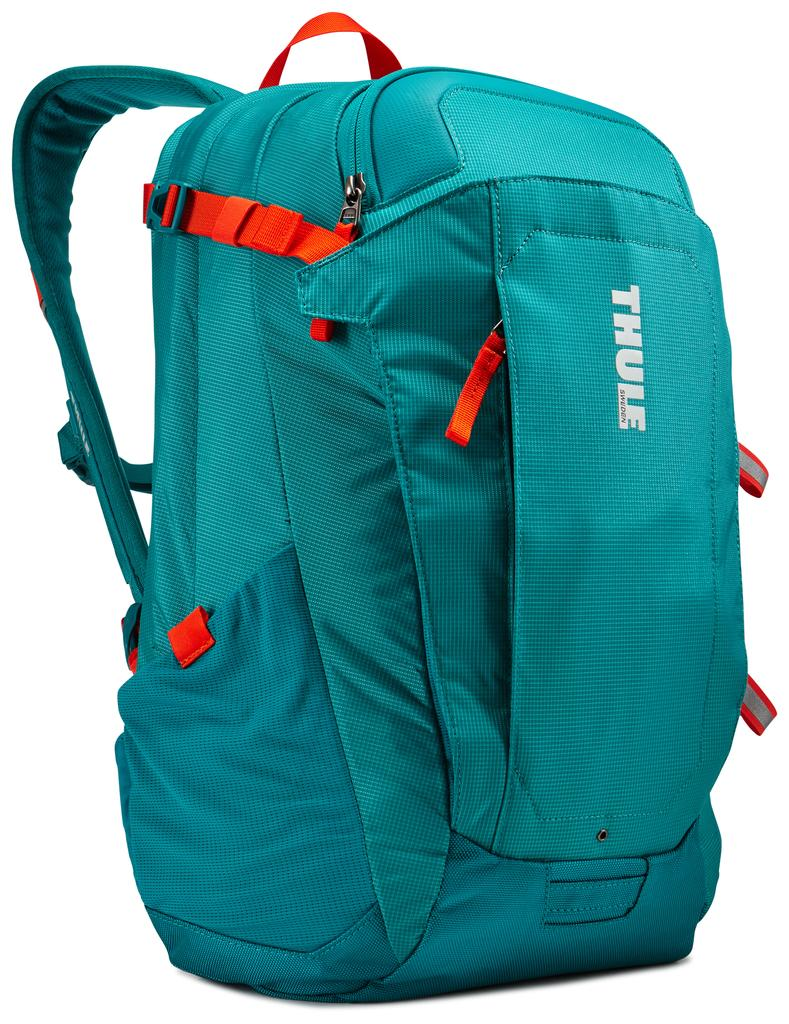<image>
Share a concise interpretation of the image provided. A teal colored backpack with red straps that says THULE on it. 